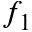<formula> <loc_0><loc_0><loc_500><loc_500>f _ { 1 }</formula> 